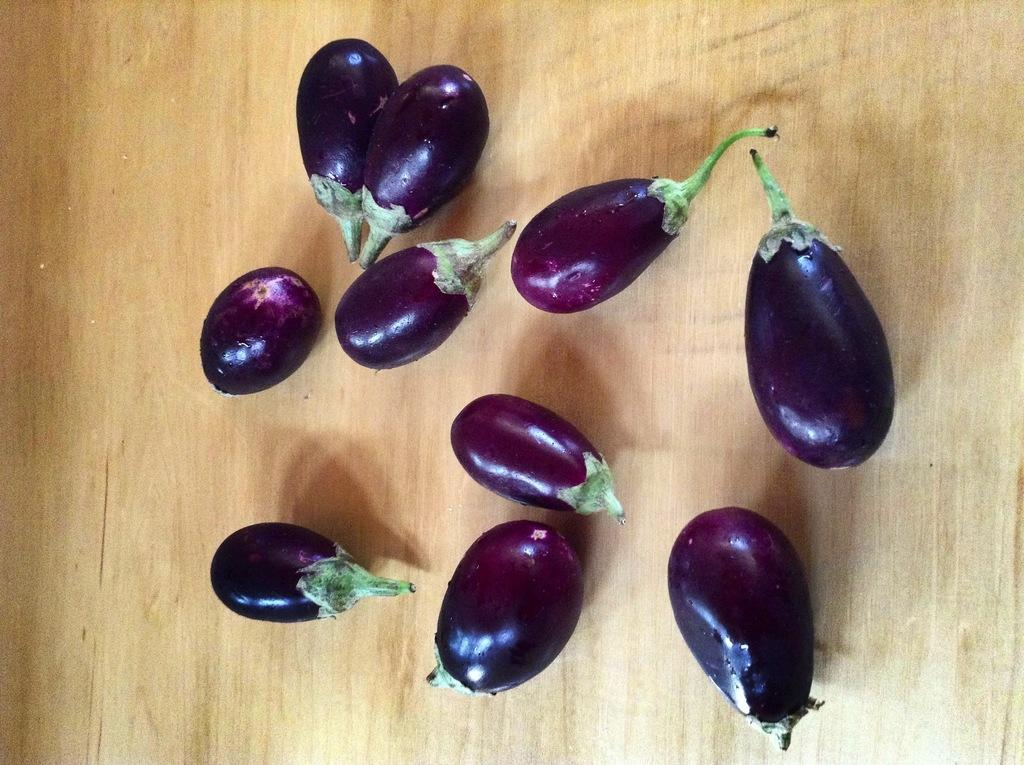What type of vegetables are present in the image? There are eggplants in the image. On what surface are the eggplants placed? The eggplants are kept on a wooden surface. How many bites can be seen on the eggplants in the image? There are no bites visible on the eggplants in the image. Who is the servant attending to in the image? There is no servant present in the image. 